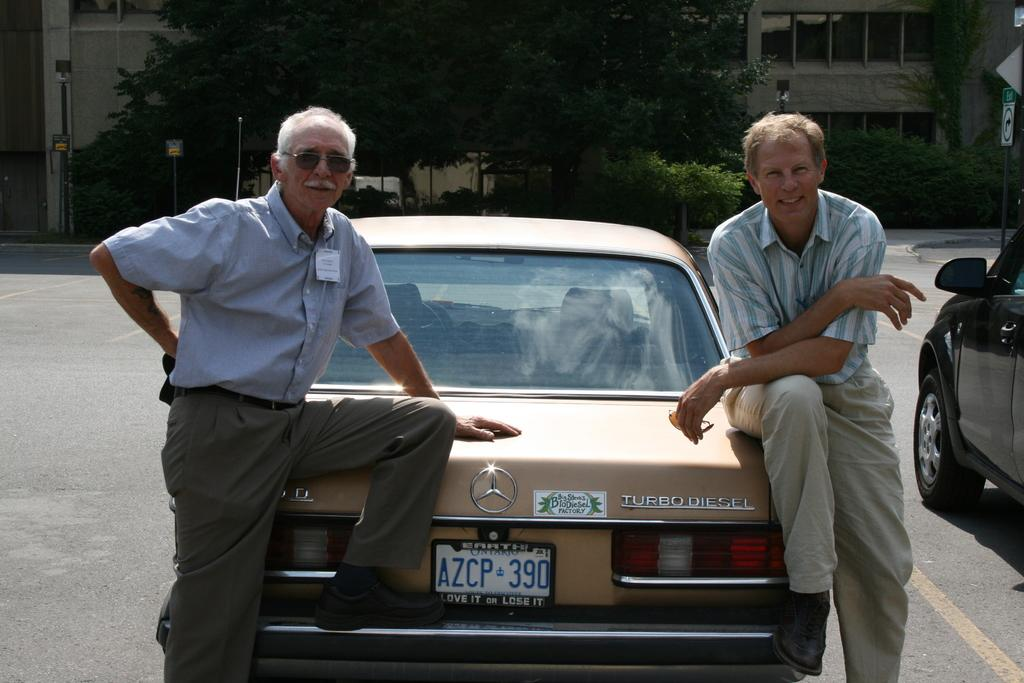How many cars are visible in the image? There are two cars in the image. What are the men in the image doing? There are two men sitting on one of the cars. What can be seen in the background of the image? There are buildings, trees, poles, and boards in the background of the image. Where is the signboard located in the image? The signboard is on the right side of the image. What type of root can be seen growing from the car in the image? There is no root growing from the car in the image. What is the heart rate of the men sitting on the car? We cannot determine the heart rate of the men sitting on the car from the image. 